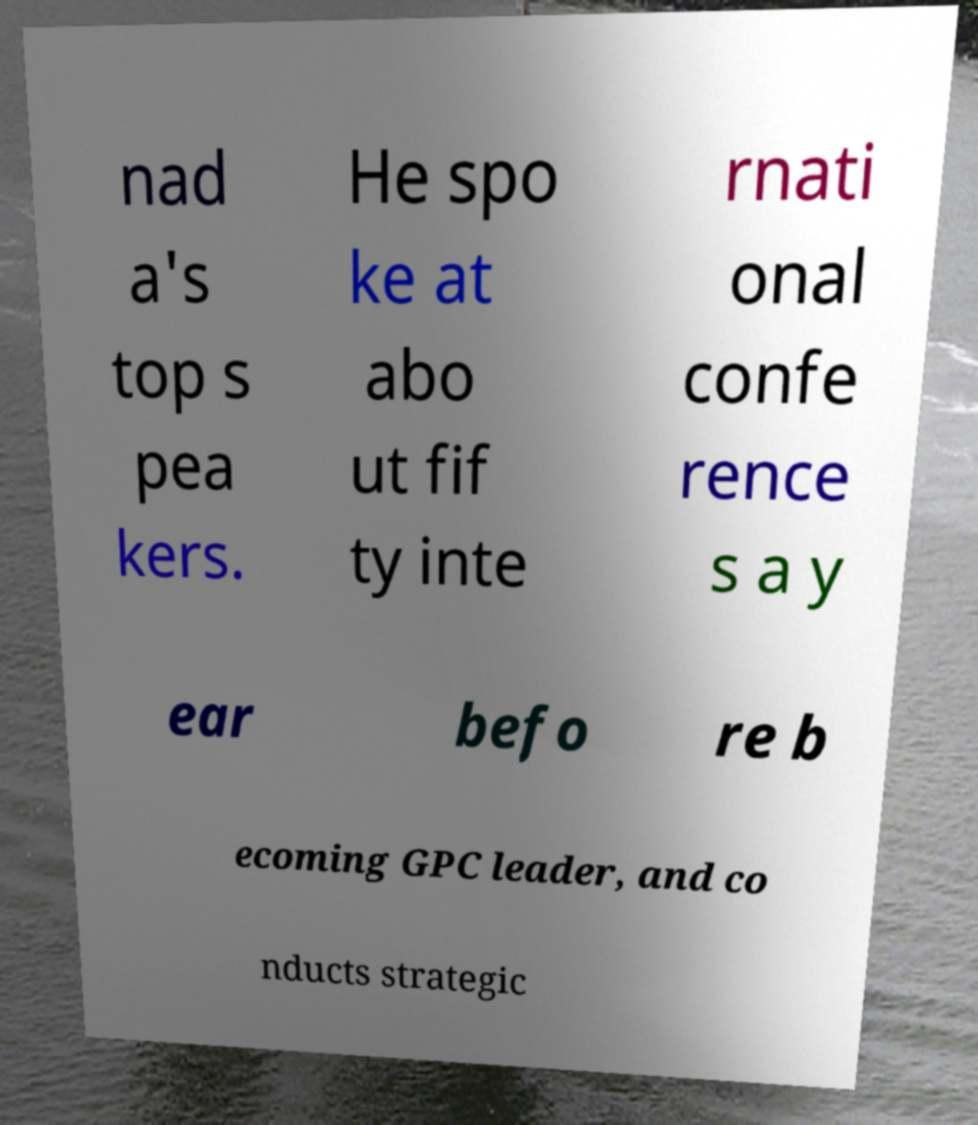Could you assist in decoding the text presented in this image and type it out clearly? nad a's top s pea kers. He spo ke at abo ut fif ty inte rnati onal confe rence s a y ear befo re b ecoming GPC leader, and co nducts strategic 